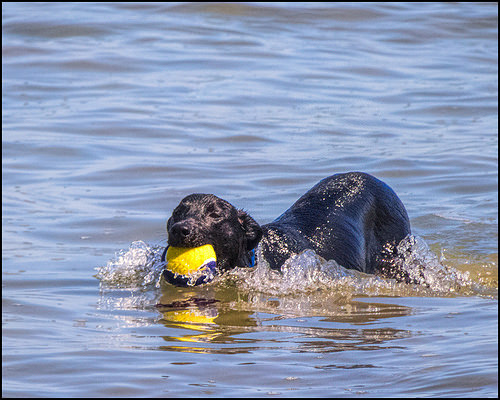<image>
Is the ball behind the dog? No. The ball is not behind the dog. From this viewpoint, the ball appears to be positioned elsewhere in the scene. 